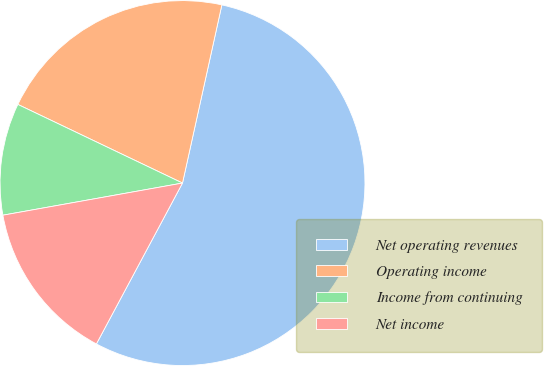<chart> <loc_0><loc_0><loc_500><loc_500><pie_chart><fcel>Net operating revenues<fcel>Operating income<fcel>Income from continuing<fcel>Net income<nl><fcel>54.36%<fcel>21.37%<fcel>9.91%<fcel>14.36%<nl></chart> 